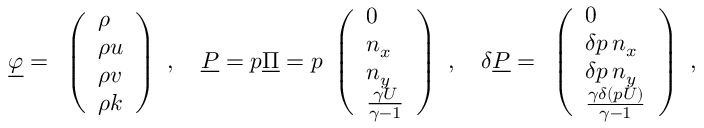Convert formula to latex. <formula><loc_0><loc_0><loc_500><loc_500>\underline { \varphi } = \begin{array} { l } { \left ( \begin{array} { l } { \rho } \\ { \rho u } \\ { \rho v } \\ { \rho k } \end{array} \right ) } \end{array} , \quad \underline { P } = p \underline { \Pi } = p \begin{array} { l } { \left ( \begin{array} { l } { 0 } \\ { n _ { x } } \\ { n _ { y } } \\ { \frac { \gamma U } { \gamma - 1 } } \end{array} \right ) } \end{array} , \quad \delta \underline { P } = \begin{array} { l } { \left ( \begin{array} { l } { 0 } \\ { \delta p \, n _ { x } } \\ { \delta p \, n _ { y } } \\ { \frac { \gamma \delta ( p U ) } { \gamma - 1 } } \end{array} \right ) } \end{array} ,</formula> 